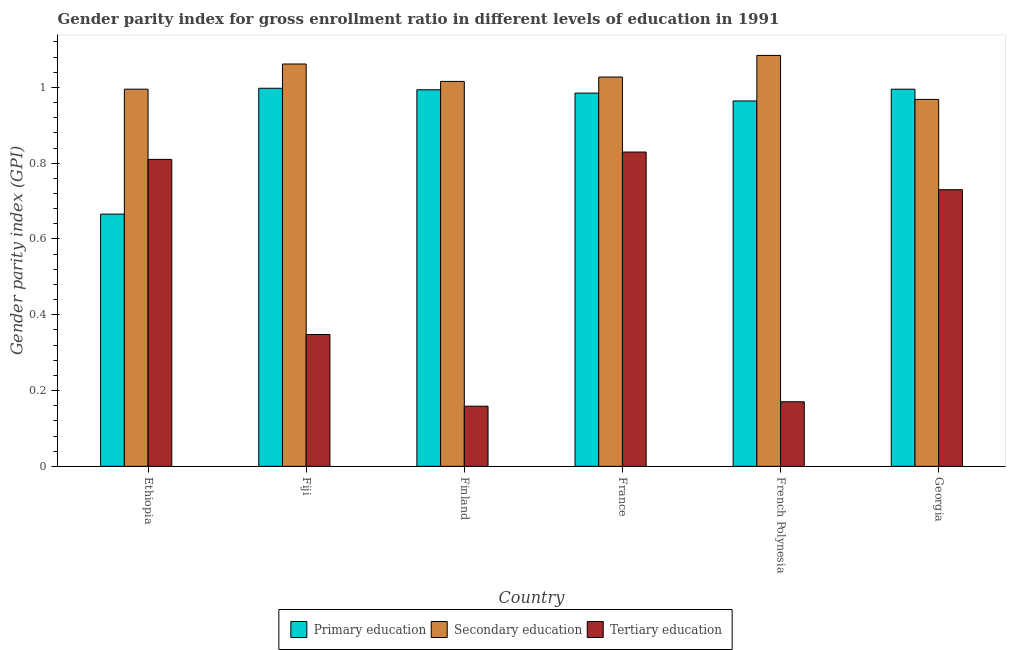How many different coloured bars are there?
Your answer should be very brief. 3. How many groups of bars are there?
Your answer should be compact. 6. Are the number of bars on each tick of the X-axis equal?
Your response must be concise. Yes. How many bars are there on the 1st tick from the left?
Your answer should be compact. 3. How many bars are there on the 4th tick from the right?
Provide a succinct answer. 3. What is the label of the 6th group of bars from the left?
Provide a succinct answer. Georgia. In how many cases, is the number of bars for a given country not equal to the number of legend labels?
Your answer should be compact. 0. What is the gender parity index in secondary education in Ethiopia?
Offer a terse response. 1. Across all countries, what is the maximum gender parity index in tertiary education?
Your response must be concise. 0.83. Across all countries, what is the minimum gender parity index in secondary education?
Provide a short and direct response. 0.97. In which country was the gender parity index in primary education minimum?
Keep it short and to the point. Ethiopia. What is the total gender parity index in secondary education in the graph?
Give a very brief answer. 6.15. What is the difference between the gender parity index in secondary education in Ethiopia and that in French Polynesia?
Keep it short and to the point. -0.09. What is the difference between the gender parity index in primary education in French Polynesia and the gender parity index in tertiary education in Georgia?
Keep it short and to the point. 0.23. What is the average gender parity index in secondary education per country?
Keep it short and to the point. 1.03. What is the difference between the gender parity index in primary education and gender parity index in tertiary education in Fiji?
Give a very brief answer. 0.65. In how many countries, is the gender parity index in tertiary education greater than 0.92 ?
Make the answer very short. 0. What is the ratio of the gender parity index in secondary education in Fiji to that in French Polynesia?
Make the answer very short. 0.98. What is the difference between the highest and the second highest gender parity index in secondary education?
Keep it short and to the point. 0.02. What is the difference between the highest and the lowest gender parity index in tertiary education?
Your answer should be compact. 0.67. What does the 3rd bar from the left in France represents?
Offer a very short reply. Tertiary education. How many countries are there in the graph?
Offer a terse response. 6. What is the difference between two consecutive major ticks on the Y-axis?
Offer a terse response. 0.2. Does the graph contain any zero values?
Keep it short and to the point. No. Does the graph contain grids?
Your answer should be very brief. No. Where does the legend appear in the graph?
Provide a succinct answer. Bottom center. How many legend labels are there?
Your response must be concise. 3. How are the legend labels stacked?
Offer a terse response. Horizontal. What is the title of the graph?
Your response must be concise. Gender parity index for gross enrollment ratio in different levels of education in 1991. What is the label or title of the X-axis?
Keep it short and to the point. Country. What is the label or title of the Y-axis?
Your answer should be compact. Gender parity index (GPI). What is the Gender parity index (GPI) in Primary education in Ethiopia?
Your answer should be very brief. 0.67. What is the Gender parity index (GPI) of Secondary education in Ethiopia?
Provide a succinct answer. 1. What is the Gender parity index (GPI) in Tertiary education in Ethiopia?
Ensure brevity in your answer.  0.81. What is the Gender parity index (GPI) in Primary education in Fiji?
Provide a succinct answer. 1. What is the Gender parity index (GPI) in Secondary education in Fiji?
Provide a succinct answer. 1.06. What is the Gender parity index (GPI) of Tertiary education in Fiji?
Ensure brevity in your answer.  0.35. What is the Gender parity index (GPI) in Primary education in Finland?
Provide a succinct answer. 0.99. What is the Gender parity index (GPI) of Secondary education in Finland?
Offer a very short reply. 1.02. What is the Gender parity index (GPI) in Tertiary education in Finland?
Provide a short and direct response. 0.16. What is the Gender parity index (GPI) in Primary education in France?
Provide a succinct answer. 0.98. What is the Gender parity index (GPI) in Secondary education in France?
Your answer should be very brief. 1.03. What is the Gender parity index (GPI) in Tertiary education in France?
Provide a succinct answer. 0.83. What is the Gender parity index (GPI) in Primary education in French Polynesia?
Make the answer very short. 0.96. What is the Gender parity index (GPI) in Secondary education in French Polynesia?
Provide a succinct answer. 1.08. What is the Gender parity index (GPI) of Tertiary education in French Polynesia?
Provide a succinct answer. 0.17. What is the Gender parity index (GPI) in Primary education in Georgia?
Keep it short and to the point. 1. What is the Gender parity index (GPI) of Secondary education in Georgia?
Make the answer very short. 0.97. What is the Gender parity index (GPI) in Tertiary education in Georgia?
Your answer should be very brief. 0.73. Across all countries, what is the maximum Gender parity index (GPI) in Primary education?
Offer a very short reply. 1. Across all countries, what is the maximum Gender parity index (GPI) in Secondary education?
Provide a short and direct response. 1.08. Across all countries, what is the maximum Gender parity index (GPI) of Tertiary education?
Provide a succinct answer. 0.83. Across all countries, what is the minimum Gender parity index (GPI) of Primary education?
Offer a terse response. 0.67. Across all countries, what is the minimum Gender parity index (GPI) in Secondary education?
Make the answer very short. 0.97. Across all countries, what is the minimum Gender parity index (GPI) of Tertiary education?
Make the answer very short. 0.16. What is the total Gender parity index (GPI) in Primary education in the graph?
Give a very brief answer. 5.6. What is the total Gender parity index (GPI) in Secondary education in the graph?
Your response must be concise. 6.15. What is the total Gender parity index (GPI) in Tertiary education in the graph?
Offer a very short reply. 3.05. What is the difference between the Gender parity index (GPI) of Primary education in Ethiopia and that in Fiji?
Keep it short and to the point. -0.33. What is the difference between the Gender parity index (GPI) in Secondary education in Ethiopia and that in Fiji?
Give a very brief answer. -0.07. What is the difference between the Gender parity index (GPI) of Tertiary education in Ethiopia and that in Fiji?
Offer a very short reply. 0.46. What is the difference between the Gender parity index (GPI) of Primary education in Ethiopia and that in Finland?
Provide a short and direct response. -0.33. What is the difference between the Gender parity index (GPI) of Secondary education in Ethiopia and that in Finland?
Make the answer very short. -0.02. What is the difference between the Gender parity index (GPI) of Tertiary education in Ethiopia and that in Finland?
Give a very brief answer. 0.65. What is the difference between the Gender parity index (GPI) in Primary education in Ethiopia and that in France?
Offer a terse response. -0.32. What is the difference between the Gender parity index (GPI) in Secondary education in Ethiopia and that in France?
Make the answer very short. -0.03. What is the difference between the Gender parity index (GPI) in Tertiary education in Ethiopia and that in France?
Keep it short and to the point. -0.02. What is the difference between the Gender parity index (GPI) of Primary education in Ethiopia and that in French Polynesia?
Your answer should be very brief. -0.3. What is the difference between the Gender parity index (GPI) of Secondary education in Ethiopia and that in French Polynesia?
Offer a very short reply. -0.09. What is the difference between the Gender parity index (GPI) in Tertiary education in Ethiopia and that in French Polynesia?
Provide a succinct answer. 0.64. What is the difference between the Gender parity index (GPI) of Primary education in Ethiopia and that in Georgia?
Ensure brevity in your answer.  -0.33. What is the difference between the Gender parity index (GPI) in Secondary education in Ethiopia and that in Georgia?
Offer a terse response. 0.03. What is the difference between the Gender parity index (GPI) in Tertiary education in Ethiopia and that in Georgia?
Provide a short and direct response. 0.08. What is the difference between the Gender parity index (GPI) of Primary education in Fiji and that in Finland?
Your answer should be very brief. 0. What is the difference between the Gender parity index (GPI) in Secondary education in Fiji and that in Finland?
Provide a succinct answer. 0.05. What is the difference between the Gender parity index (GPI) in Tertiary education in Fiji and that in Finland?
Your response must be concise. 0.19. What is the difference between the Gender parity index (GPI) of Primary education in Fiji and that in France?
Provide a succinct answer. 0.01. What is the difference between the Gender parity index (GPI) in Secondary education in Fiji and that in France?
Your answer should be very brief. 0.03. What is the difference between the Gender parity index (GPI) in Tertiary education in Fiji and that in France?
Your answer should be very brief. -0.48. What is the difference between the Gender parity index (GPI) of Primary education in Fiji and that in French Polynesia?
Provide a succinct answer. 0.03. What is the difference between the Gender parity index (GPI) in Secondary education in Fiji and that in French Polynesia?
Your answer should be compact. -0.02. What is the difference between the Gender parity index (GPI) of Tertiary education in Fiji and that in French Polynesia?
Offer a terse response. 0.18. What is the difference between the Gender parity index (GPI) of Primary education in Fiji and that in Georgia?
Give a very brief answer. 0. What is the difference between the Gender parity index (GPI) in Secondary education in Fiji and that in Georgia?
Keep it short and to the point. 0.09. What is the difference between the Gender parity index (GPI) in Tertiary education in Fiji and that in Georgia?
Offer a terse response. -0.38. What is the difference between the Gender parity index (GPI) of Primary education in Finland and that in France?
Make the answer very short. 0.01. What is the difference between the Gender parity index (GPI) in Secondary education in Finland and that in France?
Give a very brief answer. -0.01. What is the difference between the Gender parity index (GPI) in Tertiary education in Finland and that in France?
Give a very brief answer. -0.67. What is the difference between the Gender parity index (GPI) in Primary education in Finland and that in French Polynesia?
Your answer should be compact. 0.03. What is the difference between the Gender parity index (GPI) in Secondary education in Finland and that in French Polynesia?
Your response must be concise. -0.07. What is the difference between the Gender parity index (GPI) in Tertiary education in Finland and that in French Polynesia?
Give a very brief answer. -0.01. What is the difference between the Gender parity index (GPI) in Primary education in Finland and that in Georgia?
Offer a terse response. -0. What is the difference between the Gender parity index (GPI) in Secondary education in Finland and that in Georgia?
Offer a very short reply. 0.05. What is the difference between the Gender parity index (GPI) in Tertiary education in Finland and that in Georgia?
Your answer should be very brief. -0.57. What is the difference between the Gender parity index (GPI) in Primary education in France and that in French Polynesia?
Provide a short and direct response. 0.02. What is the difference between the Gender parity index (GPI) of Secondary education in France and that in French Polynesia?
Provide a succinct answer. -0.06. What is the difference between the Gender parity index (GPI) of Tertiary education in France and that in French Polynesia?
Your response must be concise. 0.66. What is the difference between the Gender parity index (GPI) in Primary education in France and that in Georgia?
Ensure brevity in your answer.  -0.01. What is the difference between the Gender parity index (GPI) of Secondary education in France and that in Georgia?
Ensure brevity in your answer.  0.06. What is the difference between the Gender parity index (GPI) in Tertiary education in France and that in Georgia?
Give a very brief answer. 0.1. What is the difference between the Gender parity index (GPI) of Primary education in French Polynesia and that in Georgia?
Your response must be concise. -0.03. What is the difference between the Gender parity index (GPI) in Secondary education in French Polynesia and that in Georgia?
Keep it short and to the point. 0.12. What is the difference between the Gender parity index (GPI) of Tertiary education in French Polynesia and that in Georgia?
Offer a very short reply. -0.56. What is the difference between the Gender parity index (GPI) in Primary education in Ethiopia and the Gender parity index (GPI) in Secondary education in Fiji?
Your answer should be very brief. -0.4. What is the difference between the Gender parity index (GPI) of Primary education in Ethiopia and the Gender parity index (GPI) of Tertiary education in Fiji?
Give a very brief answer. 0.32. What is the difference between the Gender parity index (GPI) of Secondary education in Ethiopia and the Gender parity index (GPI) of Tertiary education in Fiji?
Your answer should be compact. 0.65. What is the difference between the Gender parity index (GPI) of Primary education in Ethiopia and the Gender parity index (GPI) of Secondary education in Finland?
Give a very brief answer. -0.35. What is the difference between the Gender parity index (GPI) of Primary education in Ethiopia and the Gender parity index (GPI) of Tertiary education in Finland?
Give a very brief answer. 0.51. What is the difference between the Gender parity index (GPI) of Secondary education in Ethiopia and the Gender parity index (GPI) of Tertiary education in Finland?
Make the answer very short. 0.84. What is the difference between the Gender parity index (GPI) of Primary education in Ethiopia and the Gender parity index (GPI) of Secondary education in France?
Ensure brevity in your answer.  -0.36. What is the difference between the Gender parity index (GPI) in Primary education in Ethiopia and the Gender parity index (GPI) in Tertiary education in France?
Ensure brevity in your answer.  -0.16. What is the difference between the Gender parity index (GPI) of Secondary education in Ethiopia and the Gender parity index (GPI) of Tertiary education in France?
Offer a terse response. 0.17. What is the difference between the Gender parity index (GPI) in Primary education in Ethiopia and the Gender parity index (GPI) in Secondary education in French Polynesia?
Make the answer very short. -0.42. What is the difference between the Gender parity index (GPI) in Primary education in Ethiopia and the Gender parity index (GPI) in Tertiary education in French Polynesia?
Make the answer very short. 0.5. What is the difference between the Gender parity index (GPI) in Secondary education in Ethiopia and the Gender parity index (GPI) in Tertiary education in French Polynesia?
Offer a terse response. 0.82. What is the difference between the Gender parity index (GPI) of Primary education in Ethiopia and the Gender parity index (GPI) of Secondary education in Georgia?
Offer a terse response. -0.3. What is the difference between the Gender parity index (GPI) in Primary education in Ethiopia and the Gender parity index (GPI) in Tertiary education in Georgia?
Give a very brief answer. -0.06. What is the difference between the Gender parity index (GPI) in Secondary education in Ethiopia and the Gender parity index (GPI) in Tertiary education in Georgia?
Provide a succinct answer. 0.27. What is the difference between the Gender parity index (GPI) of Primary education in Fiji and the Gender parity index (GPI) of Secondary education in Finland?
Provide a succinct answer. -0.02. What is the difference between the Gender parity index (GPI) of Primary education in Fiji and the Gender parity index (GPI) of Tertiary education in Finland?
Offer a very short reply. 0.84. What is the difference between the Gender parity index (GPI) in Secondary education in Fiji and the Gender parity index (GPI) in Tertiary education in Finland?
Keep it short and to the point. 0.9. What is the difference between the Gender parity index (GPI) of Primary education in Fiji and the Gender parity index (GPI) of Secondary education in France?
Make the answer very short. -0.03. What is the difference between the Gender parity index (GPI) in Primary education in Fiji and the Gender parity index (GPI) in Tertiary education in France?
Ensure brevity in your answer.  0.17. What is the difference between the Gender parity index (GPI) in Secondary education in Fiji and the Gender parity index (GPI) in Tertiary education in France?
Your response must be concise. 0.23. What is the difference between the Gender parity index (GPI) of Primary education in Fiji and the Gender parity index (GPI) of Secondary education in French Polynesia?
Provide a succinct answer. -0.09. What is the difference between the Gender parity index (GPI) in Primary education in Fiji and the Gender parity index (GPI) in Tertiary education in French Polynesia?
Your answer should be very brief. 0.83. What is the difference between the Gender parity index (GPI) in Secondary education in Fiji and the Gender parity index (GPI) in Tertiary education in French Polynesia?
Provide a short and direct response. 0.89. What is the difference between the Gender parity index (GPI) in Primary education in Fiji and the Gender parity index (GPI) in Secondary education in Georgia?
Offer a terse response. 0.03. What is the difference between the Gender parity index (GPI) of Primary education in Fiji and the Gender parity index (GPI) of Tertiary education in Georgia?
Give a very brief answer. 0.27. What is the difference between the Gender parity index (GPI) in Secondary education in Fiji and the Gender parity index (GPI) in Tertiary education in Georgia?
Your answer should be very brief. 0.33. What is the difference between the Gender parity index (GPI) of Primary education in Finland and the Gender parity index (GPI) of Secondary education in France?
Your response must be concise. -0.03. What is the difference between the Gender parity index (GPI) in Primary education in Finland and the Gender parity index (GPI) in Tertiary education in France?
Ensure brevity in your answer.  0.16. What is the difference between the Gender parity index (GPI) in Secondary education in Finland and the Gender parity index (GPI) in Tertiary education in France?
Provide a short and direct response. 0.19. What is the difference between the Gender parity index (GPI) of Primary education in Finland and the Gender parity index (GPI) of Secondary education in French Polynesia?
Offer a very short reply. -0.09. What is the difference between the Gender parity index (GPI) of Primary education in Finland and the Gender parity index (GPI) of Tertiary education in French Polynesia?
Offer a terse response. 0.82. What is the difference between the Gender parity index (GPI) of Secondary education in Finland and the Gender parity index (GPI) of Tertiary education in French Polynesia?
Ensure brevity in your answer.  0.85. What is the difference between the Gender parity index (GPI) in Primary education in Finland and the Gender parity index (GPI) in Secondary education in Georgia?
Offer a terse response. 0.03. What is the difference between the Gender parity index (GPI) of Primary education in Finland and the Gender parity index (GPI) of Tertiary education in Georgia?
Your response must be concise. 0.26. What is the difference between the Gender parity index (GPI) of Secondary education in Finland and the Gender parity index (GPI) of Tertiary education in Georgia?
Keep it short and to the point. 0.29. What is the difference between the Gender parity index (GPI) in Primary education in France and the Gender parity index (GPI) in Secondary education in French Polynesia?
Provide a succinct answer. -0.1. What is the difference between the Gender parity index (GPI) of Primary education in France and the Gender parity index (GPI) of Tertiary education in French Polynesia?
Offer a terse response. 0.81. What is the difference between the Gender parity index (GPI) in Secondary education in France and the Gender parity index (GPI) in Tertiary education in French Polynesia?
Your answer should be compact. 0.86. What is the difference between the Gender parity index (GPI) of Primary education in France and the Gender parity index (GPI) of Secondary education in Georgia?
Provide a succinct answer. 0.02. What is the difference between the Gender parity index (GPI) of Primary education in France and the Gender parity index (GPI) of Tertiary education in Georgia?
Make the answer very short. 0.25. What is the difference between the Gender parity index (GPI) in Secondary education in France and the Gender parity index (GPI) in Tertiary education in Georgia?
Offer a terse response. 0.3. What is the difference between the Gender parity index (GPI) of Primary education in French Polynesia and the Gender parity index (GPI) of Secondary education in Georgia?
Keep it short and to the point. -0. What is the difference between the Gender parity index (GPI) of Primary education in French Polynesia and the Gender parity index (GPI) of Tertiary education in Georgia?
Your answer should be compact. 0.23. What is the difference between the Gender parity index (GPI) in Secondary education in French Polynesia and the Gender parity index (GPI) in Tertiary education in Georgia?
Ensure brevity in your answer.  0.35. What is the average Gender parity index (GPI) of Primary education per country?
Your response must be concise. 0.93. What is the average Gender parity index (GPI) of Secondary education per country?
Your answer should be very brief. 1.03. What is the average Gender parity index (GPI) of Tertiary education per country?
Offer a terse response. 0.51. What is the difference between the Gender parity index (GPI) of Primary education and Gender parity index (GPI) of Secondary education in Ethiopia?
Your response must be concise. -0.33. What is the difference between the Gender parity index (GPI) of Primary education and Gender parity index (GPI) of Tertiary education in Ethiopia?
Your answer should be very brief. -0.14. What is the difference between the Gender parity index (GPI) of Secondary education and Gender parity index (GPI) of Tertiary education in Ethiopia?
Make the answer very short. 0.19. What is the difference between the Gender parity index (GPI) in Primary education and Gender parity index (GPI) in Secondary education in Fiji?
Keep it short and to the point. -0.06. What is the difference between the Gender parity index (GPI) of Primary education and Gender parity index (GPI) of Tertiary education in Fiji?
Provide a short and direct response. 0.65. What is the difference between the Gender parity index (GPI) of Secondary education and Gender parity index (GPI) of Tertiary education in Fiji?
Your response must be concise. 0.71. What is the difference between the Gender parity index (GPI) of Primary education and Gender parity index (GPI) of Secondary education in Finland?
Offer a terse response. -0.02. What is the difference between the Gender parity index (GPI) of Primary education and Gender parity index (GPI) of Tertiary education in Finland?
Make the answer very short. 0.84. What is the difference between the Gender parity index (GPI) in Secondary education and Gender parity index (GPI) in Tertiary education in Finland?
Give a very brief answer. 0.86. What is the difference between the Gender parity index (GPI) of Primary education and Gender parity index (GPI) of Secondary education in France?
Your response must be concise. -0.04. What is the difference between the Gender parity index (GPI) in Primary education and Gender parity index (GPI) in Tertiary education in France?
Offer a terse response. 0.16. What is the difference between the Gender parity index (GPI) of Secondary education and Gender parity index (GPI) of Tertiary education in France?
Ensure brevity in your answer.  0.2. What is the difference between the Gender parity index (GPI) in Primary education and Gender parity index (GPI) in Secondary education in French Polynesia?
Make the answer very short. -0.12. What is the difference between the Gender parity index (GPI) of Primary education and Gender parity index (GPI) of Tertiary education in French Polynesia?
Offer a terse response. 0.79. What is the difference between the Gender parity index (GPI) in Secondary education and Gender parity index (GPI) in Tertiary education in French Polynesia?
Provide a short and direct response. 0.91. What is the difference between the Gender parity index (GPI) of Primary education and Gender parity index (GPI) of Secondary education in Georgia?
Ensure brevity in your answer.  0.03. What is the difference between the Gender parity index (GPI) in Primary education and Gender parity index (GPI) in Tertiary education in Georgia?
Your response must be concise. 0.27. What is the difference between the Gender parity index (GPI) in Secondary education and Gender parity index (GPI) in Tertiary education in Georgia?
Give a very brief answer. 0.24. What is the ratio of the Gender parity index (GPI) of Primary education in Ethiopia to that in Fiji?
Keep it short and to the point. 0.67. What is the ratio of the Gender parity index (GPI) in Secondary education in Ethiopia to that in Fiji?
Offer a very short reply. 0.94. What is the ratio of the Gender parity index (GPI) in Tertiary education in Ethiopia to that in Fiji?
Provide a succinct answer. 2.33. What is the ratio of the Gender parity index (GPI) of Primary education in Ethiopia to that in Finland?
Your answer should be very brief. 0.67. What is the ratio of the Gender parity index (GPI) in Secondary education in Ethiopia to that in Finland?
Offer a terse response. 0.98. What is the ratio of the Gender parity index (GPI) of Tertiary education in Ethiopia to that in Finland?
Make the answer very short. 5.1. What is the ratio of the Gender parity index (GPI) in Primary education in Ethiopia to that in France?
Keep it short and to the point. 0.68. What is the ratio of the Gender parity index (GPI) of Secondary education in Ethiopia to that in France?
Your answer should be very brief. 0.97. What is the ratio of the Gender parity index (GPI) in Tertiary education in Ethiopia to that in France?
Make the answer very short. 0.98. What is the ratio of the Gender parity index (GPI) of Primary education in Ethiopia to that in French Polynesia?
Your answer should be very brief. 0.69. What is the ratio of the Gender parity index (GPI) of Secondary education in Ethiopia to that in French Polynesia?
Provide a short and direct response. 0.92. What is the ratio of the Gender parity index (GPI) in Tertiary education in Ethiopia to that in French Polynesia?
Your response must be concise. 4.75. What is the ratio of the Gender parity index (GPI) in Primary education in Ethiopia to that in Georgia?
Offer a very short reply. 0.67. What is the ratio of the Gender parity index (GPI) of Secondary education in Ethiopia to that in Georgia?
Offer a very short reply. 1.03. What is the ratio of the Gender parity index (GPI) of Tertiary education in Ethiopia to that in Georgia?
Your answer should be very brief. 1.11. What is the ratio of the Gender parity index (GPI) of Primary education in Fiji to that in Finland?
Ensure brevity in your answer.  1. What is the ratio of the Gender parity index (GPI) in Secondary education in Fiji to that in Finland?
Make the answer very short. 1.05. What is the ratio of the Gender parity index (GPI) of Tertiary education in Fiji to that in Finland?
Give a very brief answer. 2.19. What is the ratio of the Gender parity index (GPI) of Primary education in Fiji to that in France?
Your answer should be very brief. 1.01. What is the ratio of the Gender parity index (GPI) of Secondary education in Fiji to that in France?
Offer a very short reply. 1.03. What is the ratio of the Gender parity index (GPI) of Tertiary education in Fiji to that in France?
Offer a very short reply. 0.42. What is the ratio of the Gender parity index (GPI) in Primary education in Fiji to that in French Polynesia?
Keep it short and to the point. 1.03. What is the ratio of the Gender parity index (GPI) of Secondary education in Fiji to that in French Polynesia?
Your response must be concise. 0.98. What is the ratio of the Gender parity index (GPI) of Tertiary education in Fiji to that in French Polynesia?
Your response must be concise. 2.04. What is the ratio of the Gender parity index (GPI) of Secondary education in Fiji to that in Georgia?
Offer a terse response. 1.1. What is the ratio of the Gender parity index (GPI) of Tertiary education in Fiji to that in Georgia?
Make the answer very short. 0.48. What is the ratio of the Gender parity index (GPI) in Primary education in Finland to that in France?
Provide a succinct answer. 1.01. What is the ratio of the Gender parity index (GPI) of Secondary education in Finland to that in France?
Your answer should be compact. 0.99. What is the ratio of the Gender parity index (GPI) in Tertiary education in Finland to that in France?
Keep it short and to the point. 0.19. What is the ratio of the Gender parity index (GPI) in Primary education in Finland to that in French Polynesia?
Make the answer very short. 1.03. What is the ratio of the Gender parity index (GPI) of Secondary education in Finland to that in French Polynesia?
Give a very brief answer. 0.94. What is the ratio of the Gender parity index (GPI) of Tertiary education in Finland to that in French Polynesia?
Provide a short and direct response. 0.93. What is the ratio of the Gender parity index (GPI) in Primary education in Finland to that in Georgia?
Keep it short and to the point. 1. What is the ratio of the Gender parity index (GPI) of Secondary education in Finland to that in Georgia?
Offer a very short reply. 1.05. What is the ratio of the Gender parity index (GPI) of Tertiary education in Finland to that in Georgia?
Give a very brief answer. 0.22. What is the ratio of the Gender parity index (GPI) in Primary education in France to that in French Polynesia?
Ensure brevity in your answer.  1.02. What is the ratio of the Gender parity index (GPI) in Tertiary education in France to that in French Polynesia?
Give a very brief answer. 4.87. What is the ratio of the Gender parity index (GPI) of Secondary education in France to that in Georgia?
Offer a terse response. 1.06. What is the ratio of the Gender parity index (GPI) in Tertiary education in France to that in Georgia?
Your answer should be very brief. 1.14. What is the ratio of the Gender parity index (GPI) of Primary education in French Polynesia to that in Georgia?
Offer a terse response. 0.97. What is the ratio of the Gender parity index (GPI) in Secondary education in French Polynesia to that in Georgia?
Offer a terse response. 1.12. What is the ratio of the Gender parity index (GPI) in Tertiary education in French Polynesia to that in Georgia?
Your answer should be compact. 0.23. What is the difference between the highest and the second highest Gender parity index (GPI) in Primary education?
Provide a short and direct response. 0. What is the difference between the highest and the second highest Gender parity index (GPI) in Secondary education?
Provide a succinct answer. 0.02. What is the difference between the highest and the second highest Gender parity index (GPI) of Tertiary education?
Make the answer very short. 0.02. What is the difference between the highest and the lowest Gender parity index (GPI) of Primary education?
Provide a short and direct response. 0.33. What is the difference between the highest and the lowest Gender parity index (GPI) in Secondary education?
Offer a terse response. 0.12. What is the difference between the highest and the lowest Gender parity index (GPI) in Tertiary education?
Give a very brief answer. 0.67. 